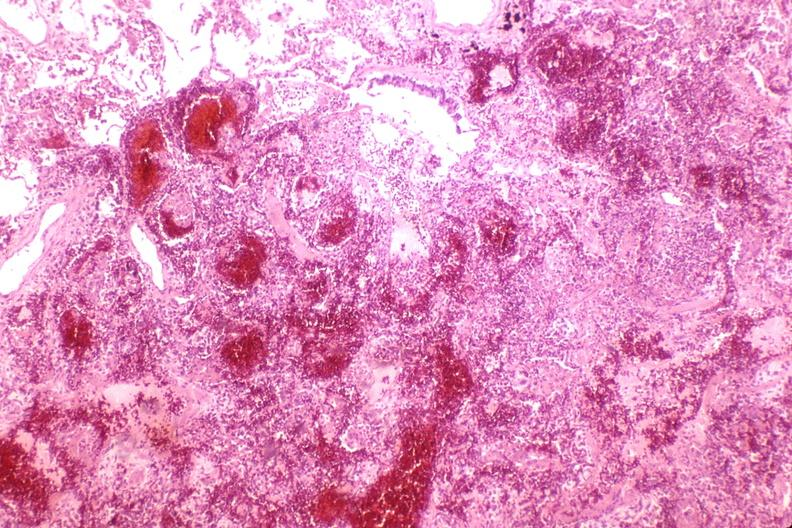what does this image show?
Answer the question using a single word or phrase. Lung 